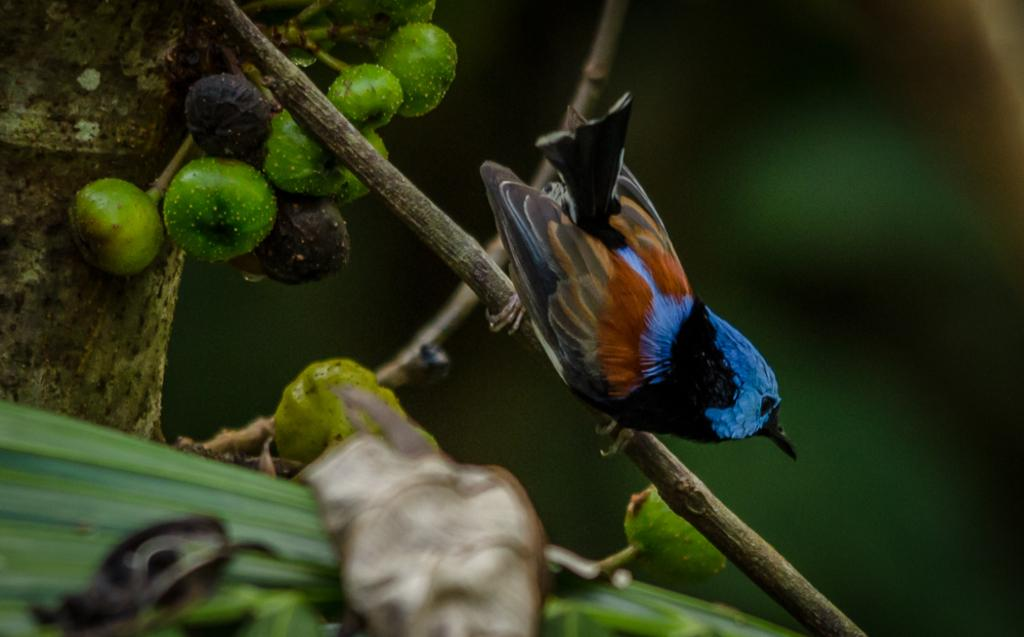What type of animal can be seen in the image? There is a bird in the image. Where is the bird located? The bird is on the branch of a tree. What else can be seen in the image besides the bird? There are fruits visible in the image. What type of beef is being served on the chair in the image? There is no beef or chair present in the image; it features a bird on a tree branch with fruits. 